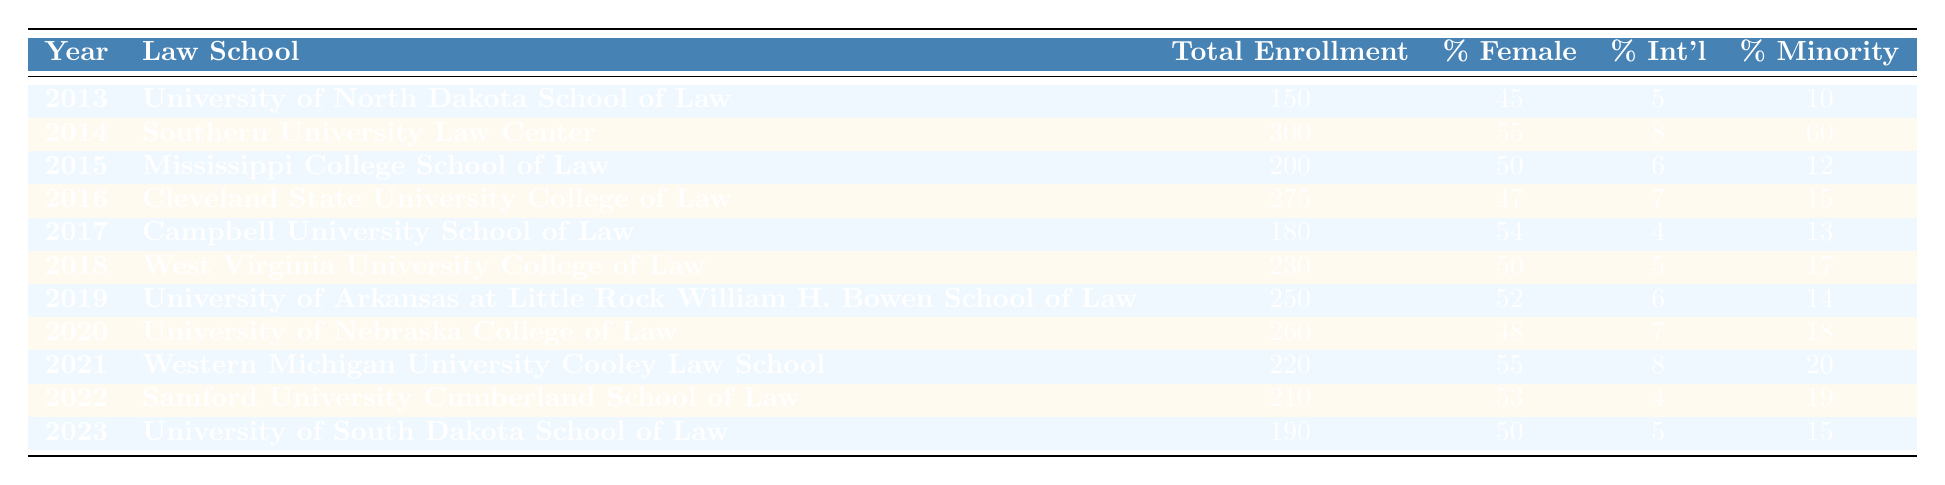What was the total enrollment at the University of Nebraska College of Law in 2020? The table shows that the total enrollment for the University of Nebraska College of Law in 2020 was 260. This can be directly retrieved from the corresponding row in the table.
Answer: 260 Which law school had the highest percentage of minority students in 2014? From the table, the Southern University Law Center in 2014 had the highest percentage of minority students at 60%. This is determined by comparing the percentage minority column for the year 2014.
Answer: 60 What was the average percentage of female students across all law schools in 2021 and 2022? For 2021, the percentage of female students at Western Michigan University Cooley Law School was 55, and for 2022, at Samford University Cumberland School of Law, it was 53. The average is calculated as (55 + 53)/2 = 108/2 = 54.
Answer: 54 Did the University of North Dakota School of Law have more than 100 students enrolled in 2013? The total enrollment for the University of North Dakota School of Law in 2013 was 150, which is more than 100. This is confirmed by looking at the total enrollment column for that specific year.
Answer: Yes What is the percentage increase in total enrollment from the year 2013 to 2014? In 2013, total enrollment was 150, and in 2014, it was 300. The increase is 300 - 150 = 150. To find the percentage increase, divide the increase by the original number (150) and multiply by 100: (150/150) * 100 = 100%.
Answer: 100% 